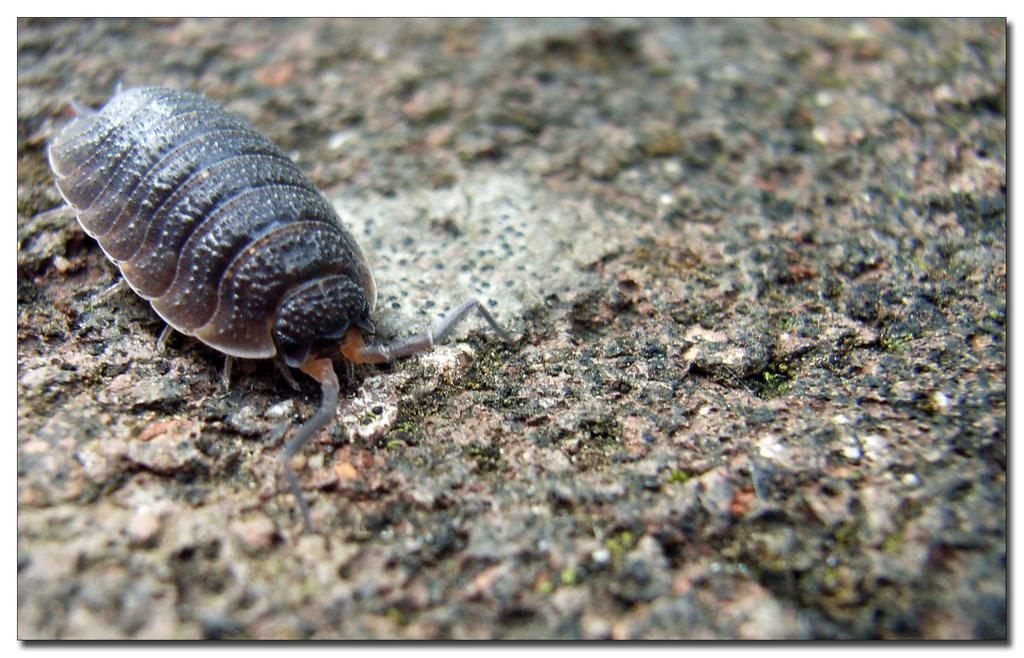What type of creature is present in the image? There is an insect in the image. Where is the insect located in the image? The insect is on the floor. What type of card is the insect holding in the image? There is no card present in the image, and the insect is not holding anything. 